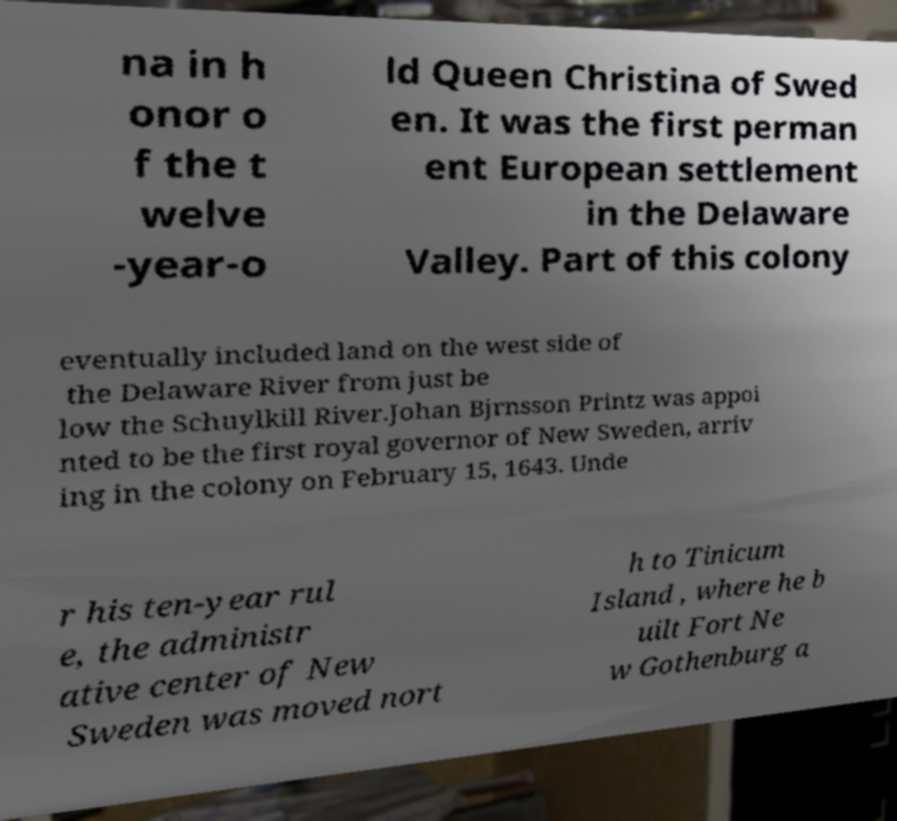Can you accurately transcribe the text from the provided image for me? na in h onor o f the t welve -year-o ld Queen Christina of Swed en. It was the first perman ent European settlement in the Delaware Valley. Part of this colony eventually included land on the west side of the Delaware River from just be low the Schuylkill River.Johan Bjrnsson Printz was appoi nted to be the first royal governor of New Sweden, arriv ing in the colony on February 15, 1643. Unde r his ten-year rul e, the administr ative center of New Sweden was moved nort h to Tinicum Island , where he b uilt Fort Ne w Gothenburg a 